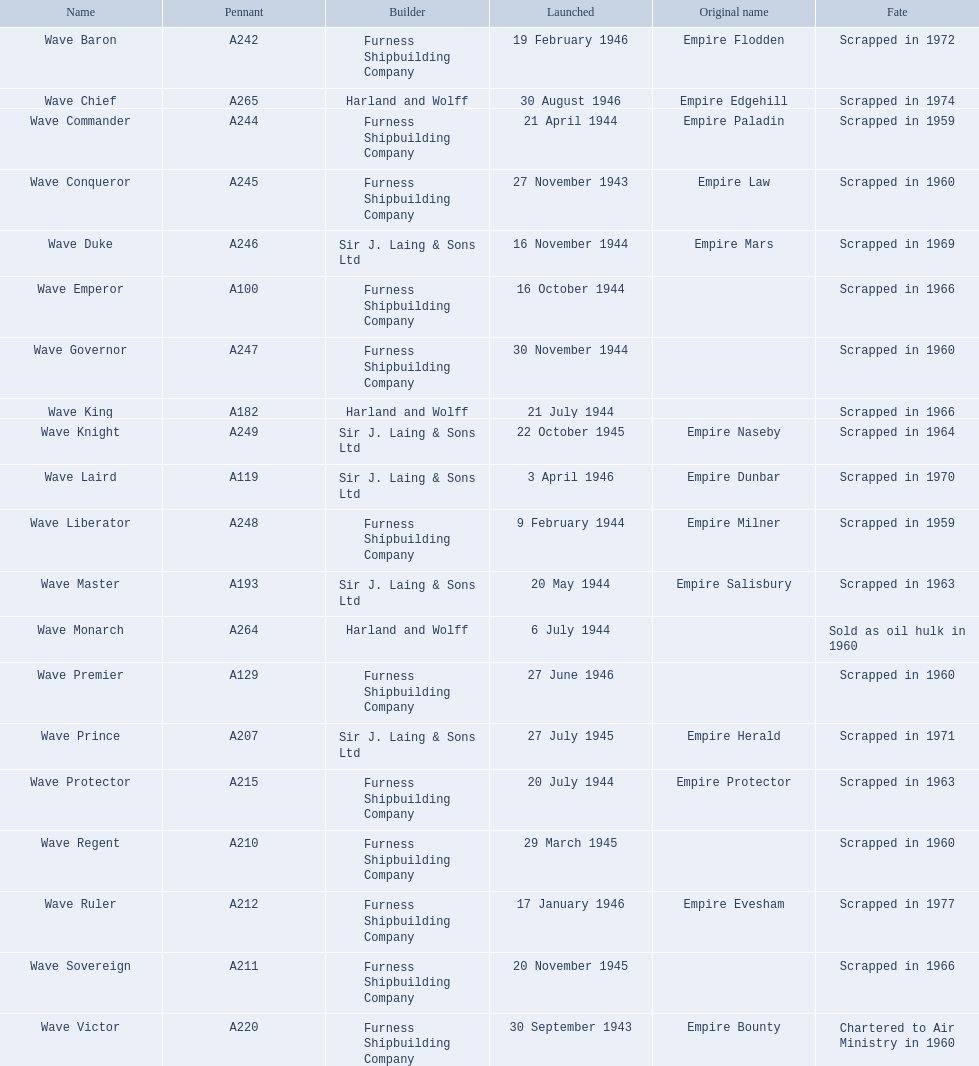Which constructors initiated vessels in november of any year? Furness Shipbuilding Company, Sir J. Laing & Sons Ltd, Furness Shipbuilding Company, Furness Shipbuilding Company. I'm looking to parse the entire table for insights. Could you assist me with that? {'header': ['Name', 'Pennant', 'Builder', 'Launched', 'Original name', 'Fate'], 'rows': [['Wave Baron', 'A242', 'Furness Shipbuilding Company', '19 February 1946', 'Empire Flodden', 'Scrapped in 1972'], ['Wave Chief', 'A265', 'Harland and Wolff', '30 August 1946', 'Empire Edgehill', 'Scrapped in 1974'], ['Wave Commander', 'A244', 'Furness Shipbuilding Company', '21 April 1944', 'Empire Paladin', 'Scrapped in 1959'], ['Wave Conqueror', 'A245', 'Furness Shipbuilding Company', '27 November 1943', 'Empire Law', 'Scrapped in 1960'], ['Wave Duke', 'A246', 'Sir J. Laing & Sons Ltd', '16 November 1944', 'Empire Mars', 'Scrapped in 1969'], ['Wave Emperor', 'A100', 'Furness Shipbuilding Company', '16 October 1944', '', 'Scrapped in 1966'], ['Wave Governor', 'A247', 'Furness Shipbuilding Company', '30 November 1944', '', 'Scrapped in 1960'], ['Wave King', 'A182', 'Harland and Wolff', '21 July 1944', '', 'Scrapped in 1966'], ['Wave Knight', 'A249', 'Sir J. Laing & Sons Ltd', '22 October 1945', 'Empire Naseby', 'Scrapped in 1964'], ['Wave Laird', 'A119', 'Sir J. Laing & Sons Ltd', '3 April 1946', 'Empire Dunbar', 'Scrapped in 1970'], ['Wave Liberator', 'A248', 'Furness Shipbuilding Company', '9 February 1944', 'Empire Milner', 'Scrapped in 1959'], ['Wave Master', 'A193', 'Sir J. Laing & Sons Ltd', '20 May 1944', 'Empire Salisbury', 'Scrapped in 1963'], ['Wave Monarch', 'A264', 'Harland and Wolff', '6 July 1944', '', 'Sold as oil hulk in 1960'], ['Wave Premier', 'A129', 'Furness Shipbuilding Company', '27 June 1946', '', 'Scrapped in 1960'], ['Wave Prince', 'A207', 'Sir J. Laing & Sons Ltd', '27 July 1945', 'Empire Herald', 'Scrapped in 1971'], ['Wave Protector', 'A215', 'Furness Shipbuilding Company', '20 July 1944', 'Empire Protector', 'Scrapped in 1963'], ['Wave Regent', 'A210', 'Furness Shipbuilding Company', '29 March 1945', '', 'Scrapped in 1960'], ['Wave Ruler', 'A212', 'Furness Shipbuilding Company', '17 January 1946', 'Empire Evesham', 'Scrapped in 1977'], ['Wave Sovereign', 'A211', 'Furness Shipbuilding Company', '20 November 1945', '', 'Scrapped in 1966'], ['Wave Victor', 'A220', 'Furness Shipbuilding Company', '30 September 1943', 'Empire Bounty', 'Chartered to Air Ministry in 1960']]} What ship constructors' vessels had their initial names altered before dismantling? Furness Shipbuilding Company, Sir J. Laing & Sons Ltd. What was the designation of the vessel that was constructed in november and had its name modified before being dismantled just 12 years following its initiation? Wave Conqueror. 